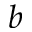Convert formula to latex. <formula><loc_0><loc_0><loc_500><loc_500>^ { b }</formula> 